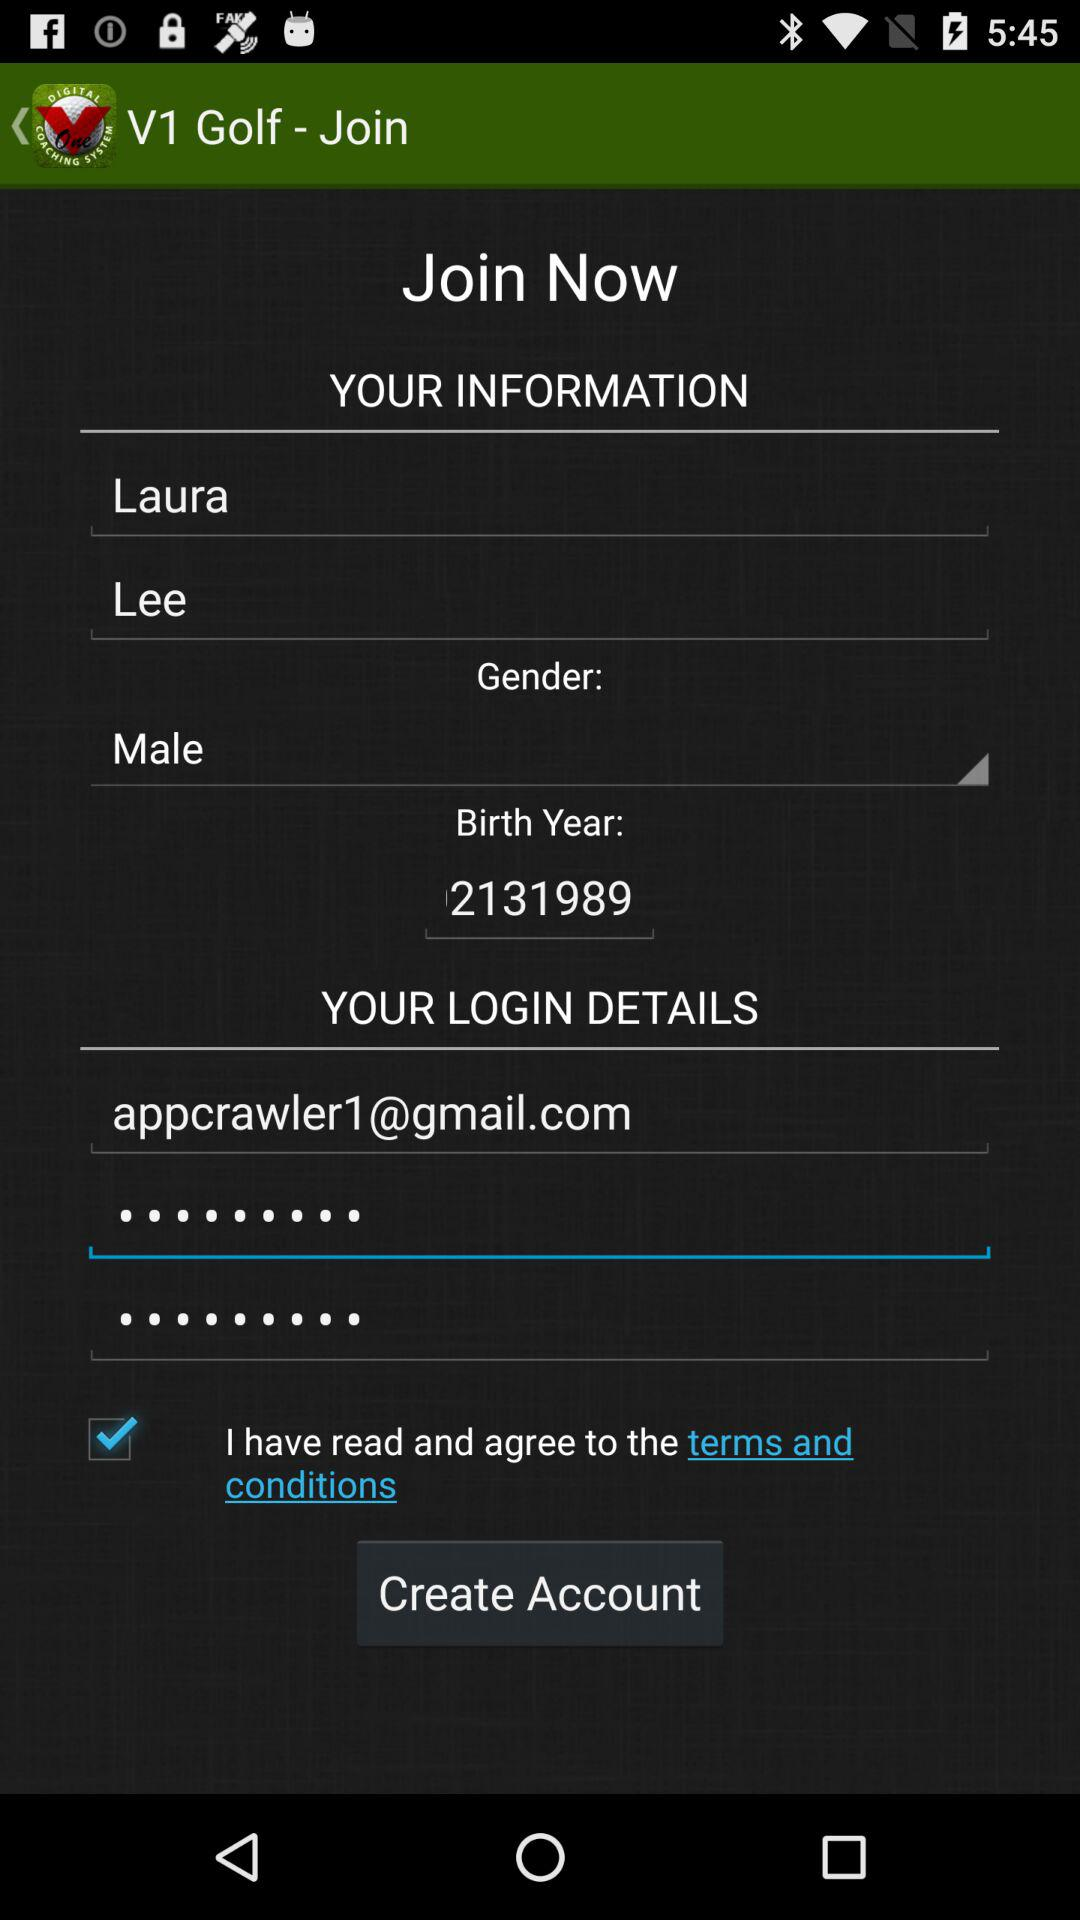What is the name of the person? The name of the person is Laura Lee. 